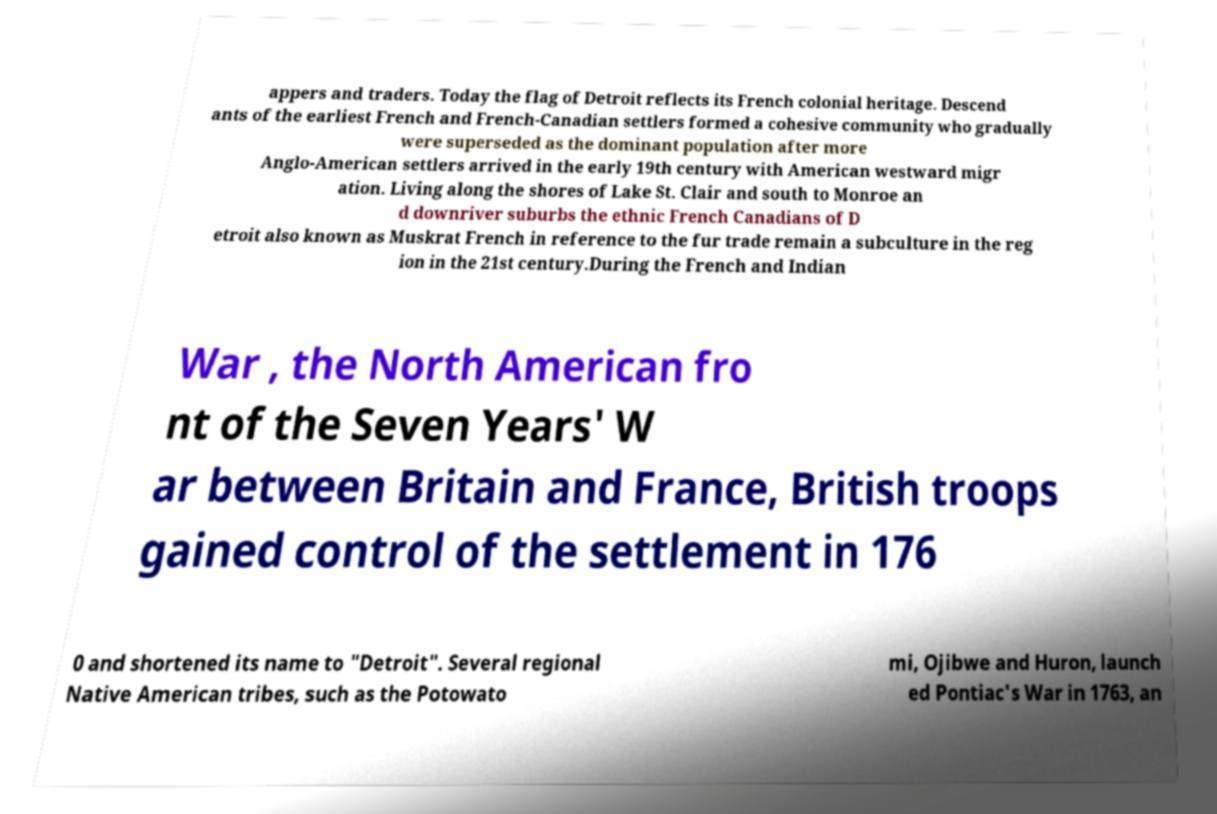For documentation purposes, I need the text within this image transcribed. Could you provide that? appers and traders. Today the flag of Detroit reflects its French colonial heritage. Descend ants of the earliest French and French-Canadian settlers formed a cohesive community who gradually were superseded as the dominant population after more Anglo-American settlers arrived in the early 19th century with American westward migr ation. Living along the shores of Lake St. Clair and south to Monroe an d downriver suburbs the ethnic French Canadians of D etroit also known as Muskrat French in reference to the fur trade remain a subculture in the reg ion in the 21st century.During the French and Indian War , the North American fro nt of the Seven Years' W ar between Britain and France, British troops gained control of the settlement in 176 0 and shortened its name to "Detroit". Several regional Native American tribes, such as the Potowato mi, Ojibwe and Huron, launch ed Pontiac's War in 1763, an 